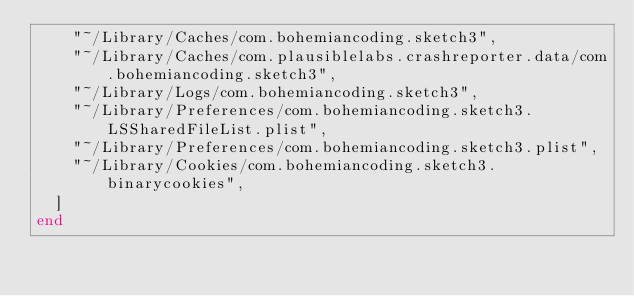<code> <loc_0><loc_0><loc_500><loc_500><_Ruby_>    "~/Library/Caches/com.bohemiancoding.sketch3",
    "~/Library/Caches/com.plausiblelabs.crashreporter.data/com.bohemiancoding.sketch3",
    "~/Library/Logs/com.bohemiancoding.sketch3",
    "~/Library/Preferences/com.bohemiancoding.sketch3.LSSharedFileList.plist",
    "~/Library/Preferences/com.bohemiancoding.sketch3.plist",
    "~/Library/Cookies/com.bohemiancoding.sketch3.binarycookies",
  ]
end
</code> 